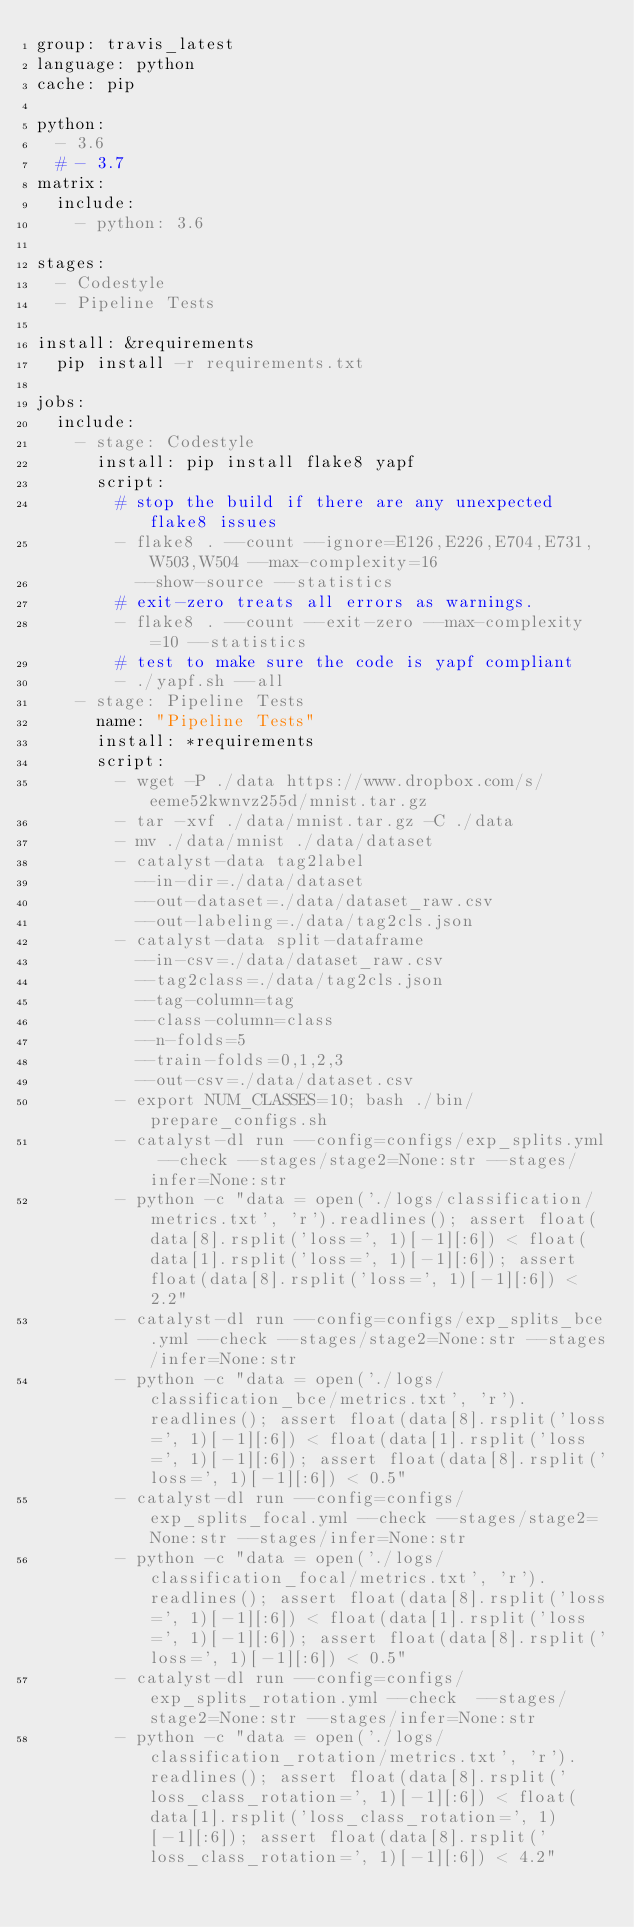Convert code to text. <code><loc_0><loc_0><loc_500><loc_500><_YAML_>group: travis_latest
language: python
cache: pip

python:
  - 3.6
  # - 3.7
matrix:
  include:
    - python: 3.6

stages:
  - Codestyle
  - Pipeline Tests

install: &requirements
  pip install -r requirements.txt

jobs:
  include:
    - stage: Codestyle
      install: pip install flake8 yapf
      script:
        # stop the build if there are any unexpected flake8 issues
        - flake8 . --count --ignore=E126,E226,E704,E731,W503,W504 --max-complexity=16
          --show-source --statistics
        # exit-zero treats all errors as warnings.
        - flake8 . --count --exit-zero --max-complexity=10 --statistics
        # test to make sure the code is yapf compliant
        - ./yapf.sh --all
    - stage: Pipeline Tests
      name: "Pipeline Tests"
      install: *requirements
      script:
        - wget -P ./data https://www.dropbox.com/s/eeme52kwnvz255d/mnist.tar.gz
        - tar -xvf ./data/mnist.tar.gz -C ./data
        - mv ./data/mnist ./data/dataset
        - catalyst-data tag2label
          --in-dir=./data/dataset
          --out-dataset=./data/dataset_raw.csv
          --out-labeling=./data/tag2cls.json
        - catalyst-data split-dataframe
          --in-csv=./data/dataset_raw.csv
          --tag2class=./data/tag2cls.json
          --tag-column=tag
          --class-column=class
          --n-folds=5
          --train-folds=0,1,2,3
          --out-csv=./data/dataset.csv
        - export NUM_CLASSES=10; bash ./bin/prepare_configs.sh
        - catalyst-dl run --config=configs/exp_splits.yml --check --stages/stage2=None:str --stages/infer=None:str
        - python -c "data = open('./logs/classification/metrics.txt', 'r').readlines(); assert float(data[8].rsplit('loss=', 1)[-1][:6]) < float(data[1].rsplit('loss=', 1)[-1][:6]); assert float(data[8].rsplit('loss=', 1)[-1][:6]) < 2.2"
        - catalyst-dl run --config=configs/exp_splits_bce.yml --check --stages/stage2=None:str --stages/infer=None:str
        - python -c "data = open('./logs/classification_bce/metrics.txt', 'r').readlines(); assert float(data[8].rsplit('loss=', 1)[-1][:6]) < float(data[1].rsplit('loss=', 1)[-1][:6]); assert float(data[8].rsplit('loss=', 1)[-1][:6]) < 0.5"
        - catalyst-dl run --config=configs/exp_splits_focal.yml --check --stages/stage2=None:str --stages/infer=None:str
        - python -c "data = open('./logs/classification_focal/metrics.txt', 'r').readlines(); assert float(data[8].rsplit('loss=', 1)[-1][:6]) < float(data[1].rsplit('loss=', 1)[-1][:6]); assert float(data[8].rsplit('loss=', 1)[-1][:6]) < 0.5"
        - catalyst-dl run --config=configs/exp_splits_rotation.yml --check  --stages/stage2=None:str --stages/infer=None:str
        - python -c "data = open('./logs/classification_rotation/metrics.txt', 'r').readlines(); assert float(data[8].rsplit('loss_class_rotation=', 1)[-1][:6]) < float(data[1].rsplit('loss_class_rotation=', 1)[-1][:6]); assert float(data[8].rsplit('loss_class_rotation=', 1)[-1][:6]) < 4.2"
</code> 